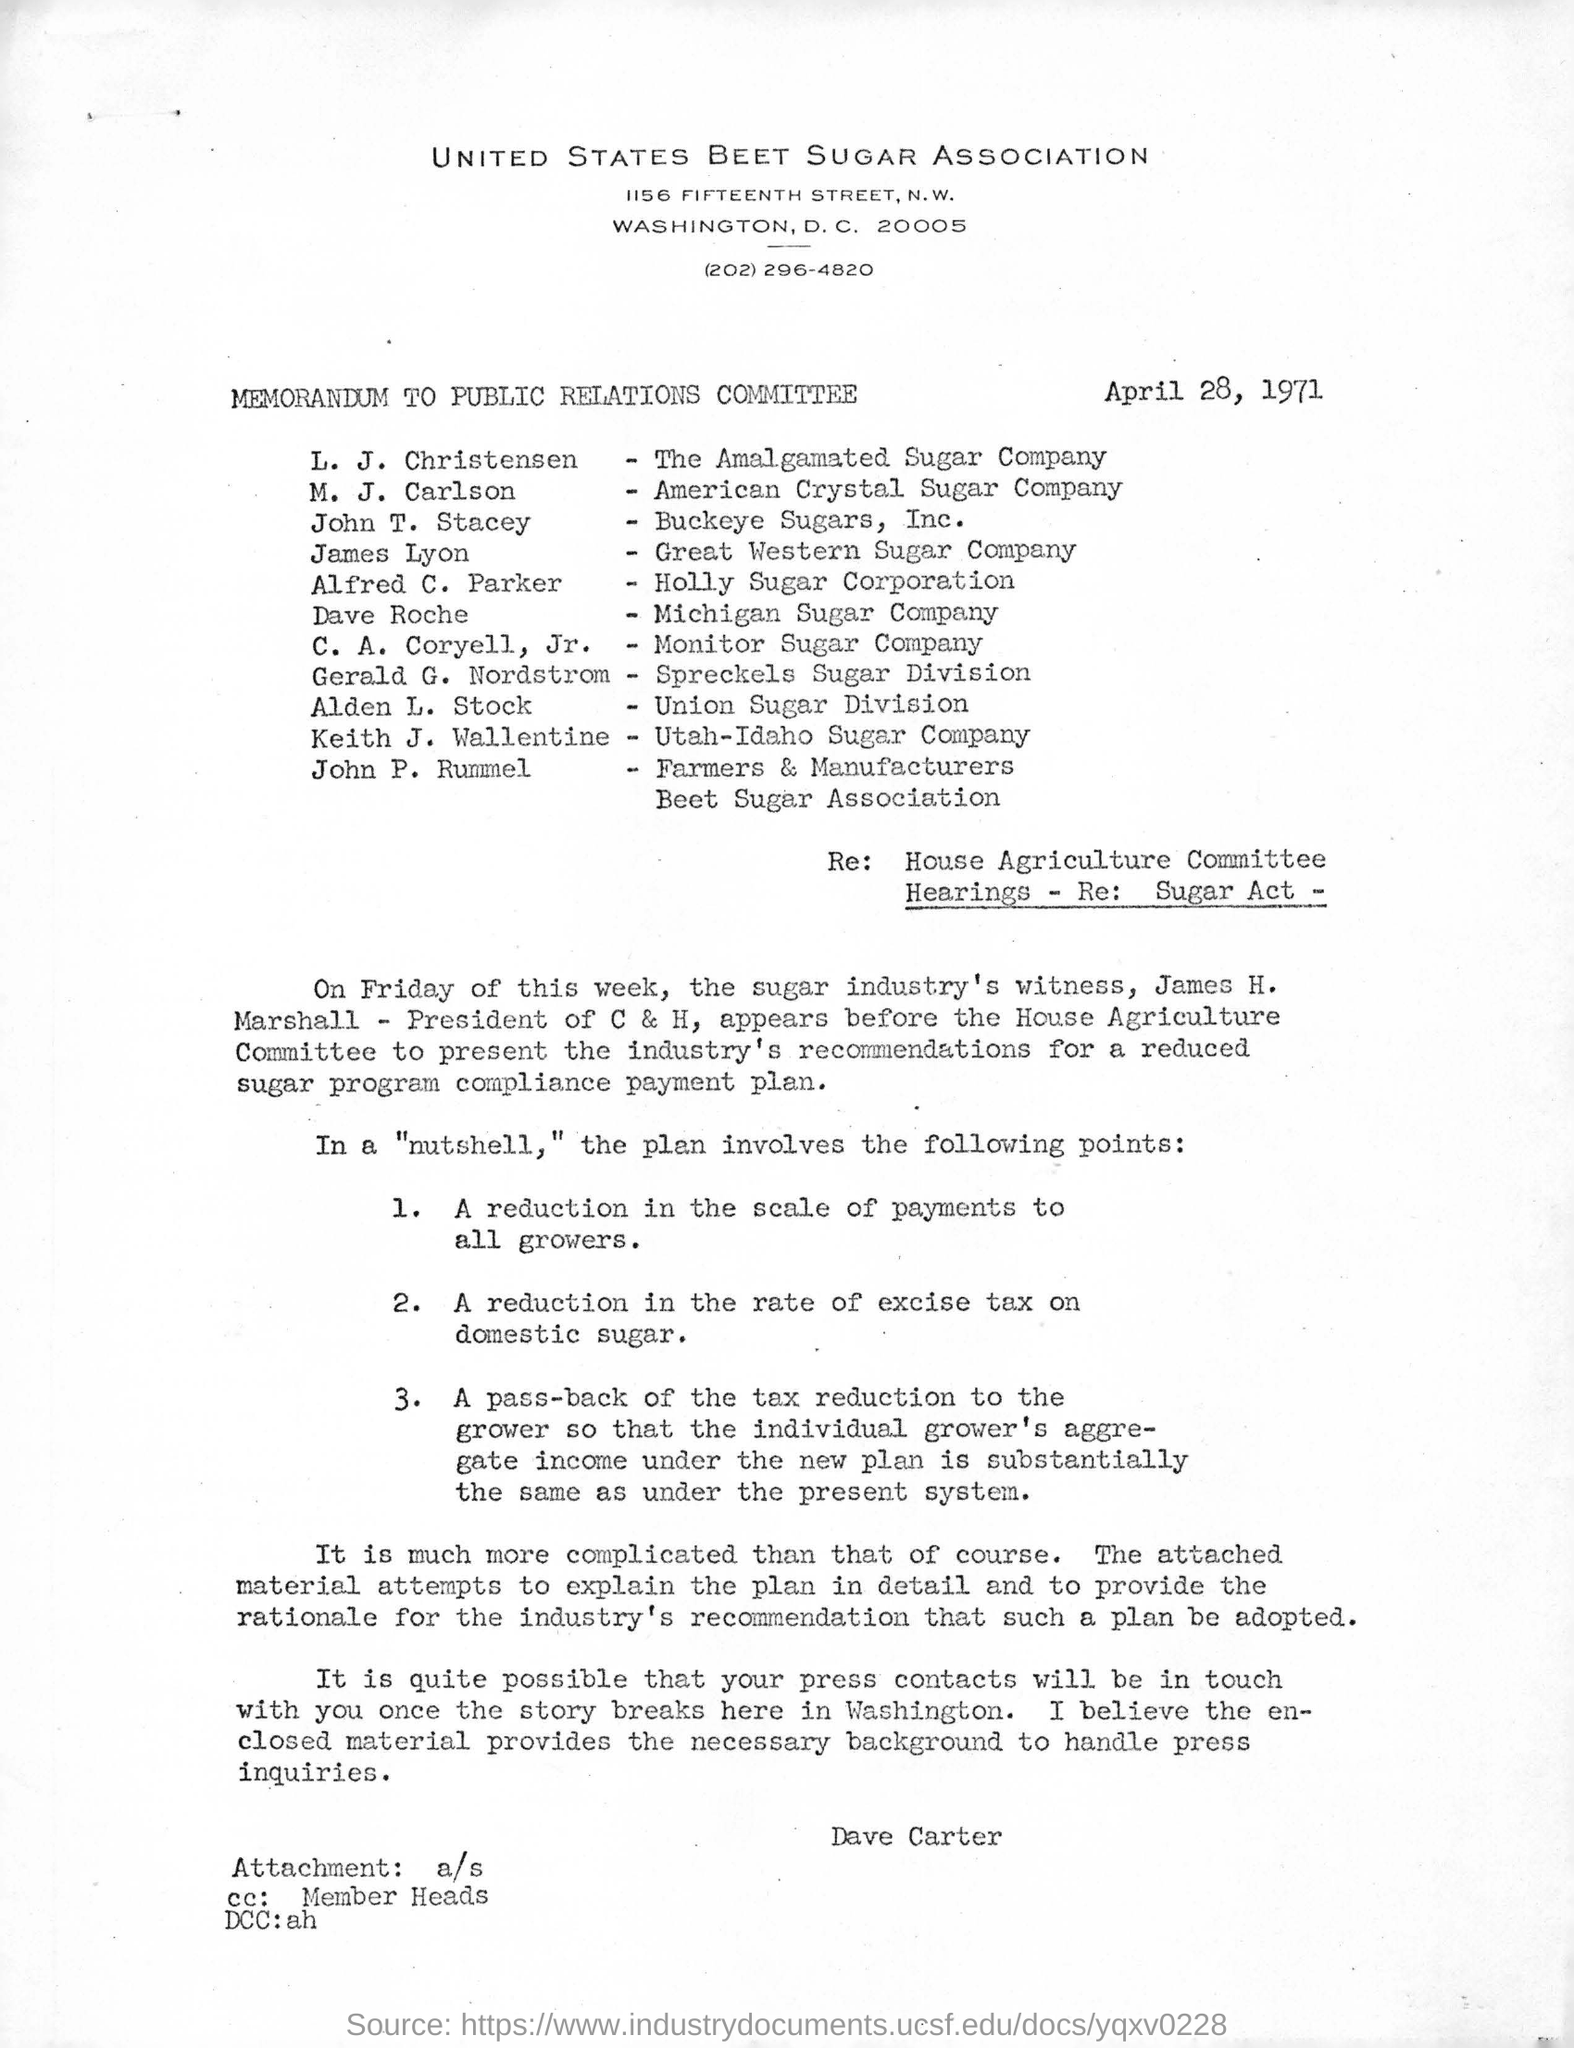What is the name of the association mentioned ?
Offer a terse response. United states beet sugar association. What is the date mentioned in the given page ?
Your answer should be compact. April 28, 1971. To which company l.j.christensen belongs to ?
Give a very brief answer. The amalgamated sugar company. To which company m.j. carlson belongs to ?
Give a very brief answer. American Crystal Sugar Company. To which company james lyon belongs to ?
Provide a short and direct response. Great western sugar company. To which company dave roche belongs to ?
Give a very brief answer. Michigan sugar company. To which company keith j. wallentine belongs to ?
Your response must be concise. Utah-Idaho sugar company. 